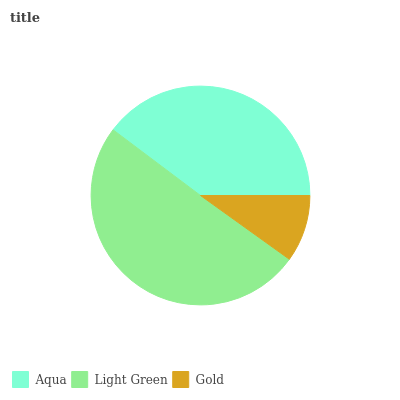Is Gold the minimum?
Answer yes or no. Yes. Is Light Green the maximum?
Answer yes or no. Yes. Is Light Green the minimum?
Answer yes or no. No. Is Gold the maximum?
Answer yes or no. No. Is Light Green greater than Gold?
Answer yes or no. Yes. Is Gold less than Light Green?
Answer yes or no. Yes. Is Gold greater than Light Green?
Answer yes or no. No. Is Light Green less than Gold?
Answer yes or no. No. Is Aqua the high median?
Answer yes or no. Yes. Is Aqua the low median?
Answer yes or no. Yes. Is Gold the high median?
Answer yes or no. No. Is Gold the low median?
Answer yes or no. No. 